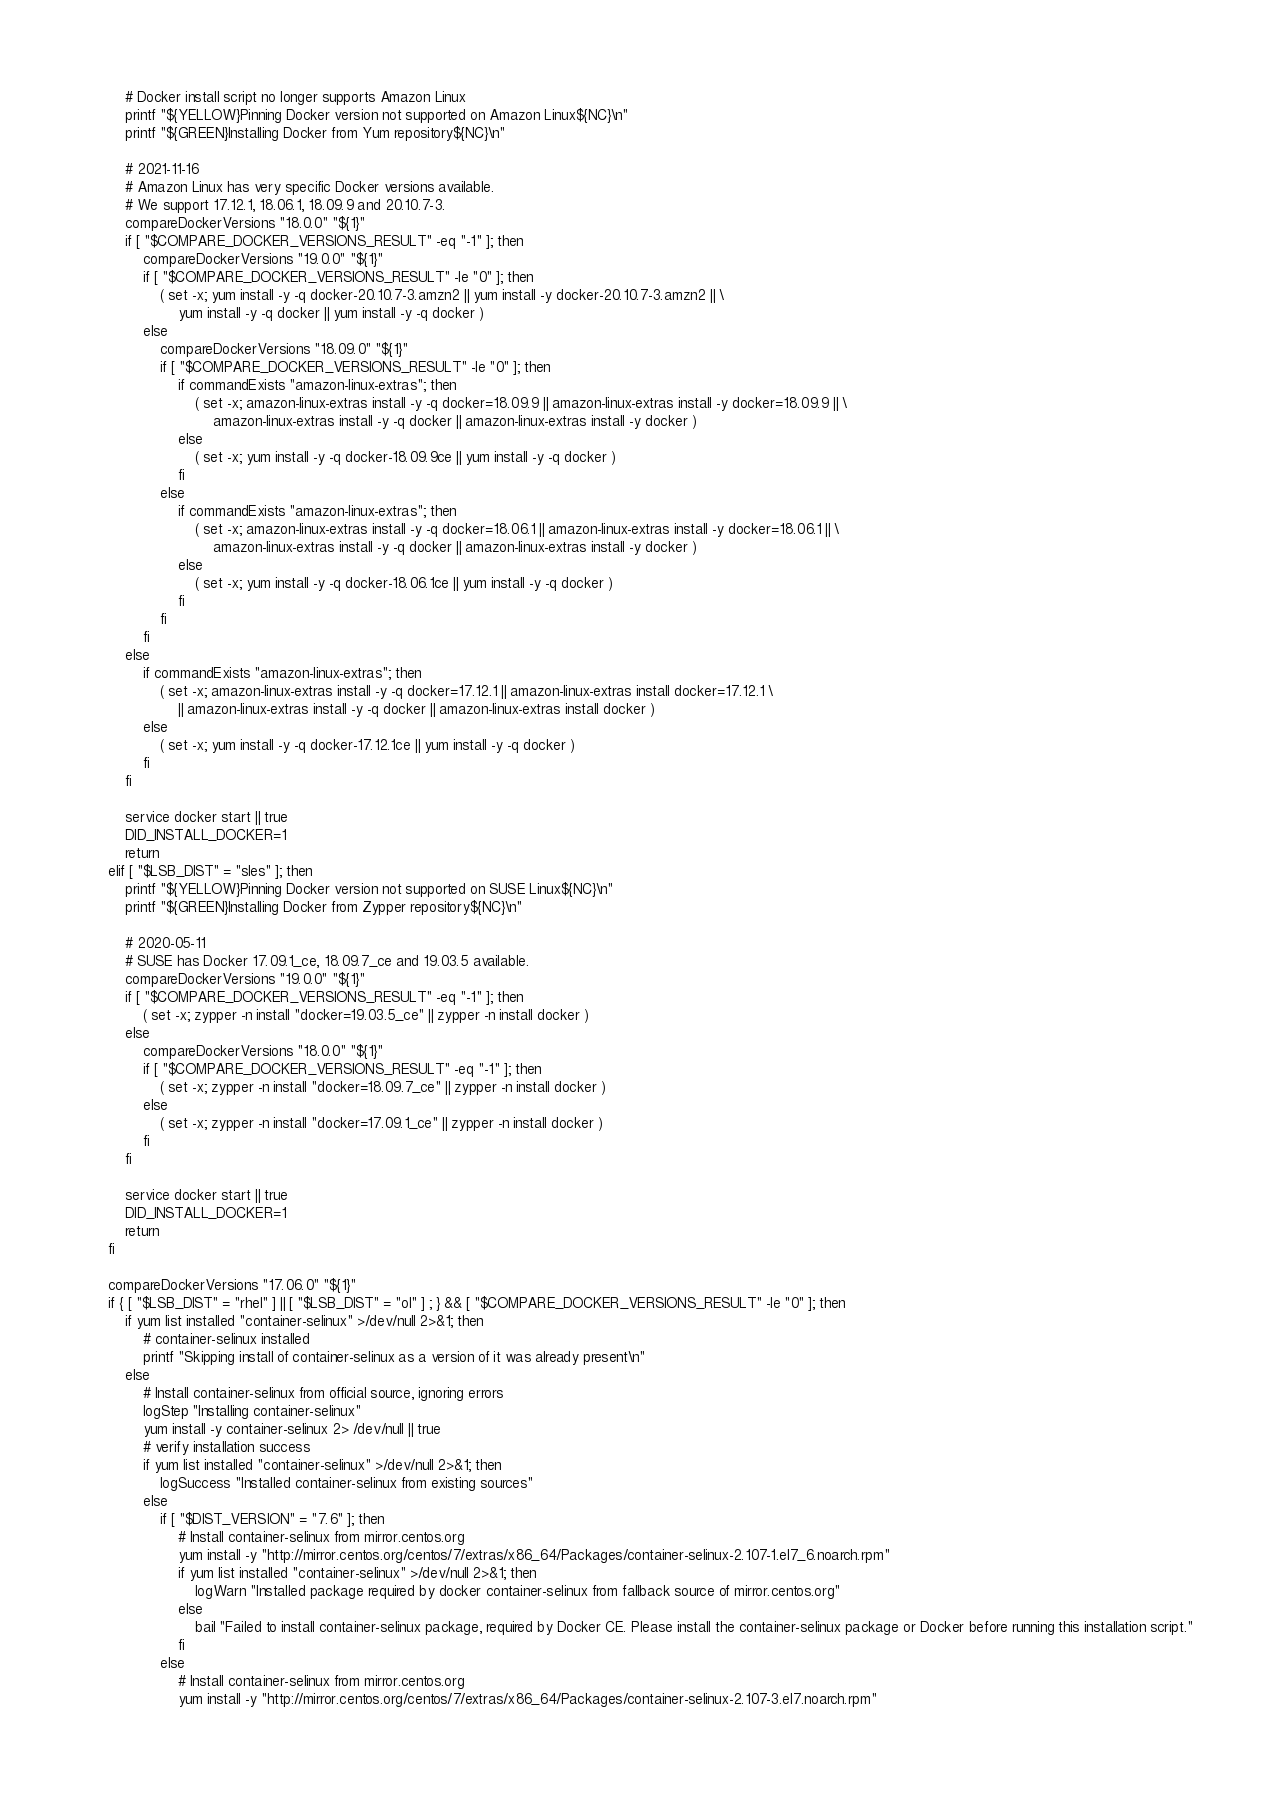Convert code to text. <code><loc_0><loc_0><loc_500><loc_500><_Bash_>        # Docker install script no longer supports Amazon Linux
        printf "${YELLOW}Pinning Docker version not supported on Amazon Linux${NC}\n"
        printf "${GREEN}Installing Docker from Yum repository${NC}\n"

        # 2021-11-16
        # Amazon Linux has very specific Docker versions available.
        # We support 17.12.1, 18.06.1, 18.09.9 and 20.10.7-3.
        compareDockerVersions "18.0.0" "${1}"
        if [ "$COMPARE_DOCKER_VERSIONS_RESULT" -eq "-1" ]; then
            compareDockerVersions "19.0.0" "${1}"
            if [ "$COMPARE_DOCKER_VERSIONS_RESULT" -le "0" ]; then
                ( set -x; yum install -y -q docker-20.10.7-3.amzn2 || yum install -y docker-20.10.7-3.amzn2 || \
                    yum install -y -q docker || yum install -y -q docker )
            else
                compareDockerVersions "18.09.0" "${1}"
                if [ "$COMPARE_DOCKER_VERSIONS_RESULT" -le "0" ]; then
                    if commandExists "amazon-linux-extras"; then
                        ( set -x; amazon-linux-extras install -y -q docker=18.09.9 || amazon-linux-extras install -y docker=18.09.9 || \
                            amazon-linux-extras install -y -q docker || amazon-linux-extras install -y docker )
                    else
                        ( set -x; yum install -y -q docker-18.09.9ce || yum install -y -q docker )
                    fi
                else
                    if commandExists "amazon-linux-extras"; then
                        ( set -x; amazon-linux-extras install -y -q docker=18.06.1 || amazon-linux-extras install -y docker=18.06.1 || \
                            amazon-linux-extras install -y -q docker || amazon-linux-extras install -y docker )
                    else
                        ( set -x; yum install -y -q docker-18.06.1ce || yum install -y -q docker )
                    fi
                fi
            fi
        else
            if commandExists "amazon-linux-extras"; then
                ( set -x; amazon-linux-extras install -y -q docker=17.12.1 || amazon-linux-extras install docker=17.12.1 \
                    || amazon-linux-extras install -y -q docker || amazon-linux-extras install docker )
            else
                ( set -x; yum install -y -q docker-17.12.1ce || yum install -y -q docker )
            fi
        fi

        service docker start || true
        DID_INSTALL_DOCKER=1
        return
    elif [ "$LSB_DIST" = "sles" ]; then
        printf "${YELLOW}Pinning Docker version not supported on SUSE Linux${NC}\n"
        printf "${GREEN}Installing Docker from Zypper repository${NC}\n"

        # 2020-05-11
        # SUSE has Docker 17.09.1_ce, 18.09.7_ce and 19.03.5 available.
        compareDockerVersions "19.0.0" "${1}"
        if [ "$COMPARE_DOCKER_VERSIONS_RESULT" -eq "-1" ]; then
            ( set -x; zypper -n install "docker=19.03.5_ce" || zypper -n install docker )
        else
            compareDockerVersions "18.0.0" "${1}"
            if [ "$COMPARE_DOCKER_VERSIONS_RESULT" -eq "-1" ]; then
                ( set -x; zypper -n install "docker=18.09.7_ce" || zypper -n install docker )
            else
                ( set -x; zypper -n install "docker=17.09.1_ce" || zypper -n install docker )
            fi
        fi

        service docker start || true
        DID_INSTALL_DOCKER=1
        return
    fi

    compareDockerVersions "17.06.0" "${1}"
    if { [ "$LSB_DIST" = "rhel" ] || [ "$LSB_DIST" = "ol" ] ; } && [ "$COMPARE_DOCKER_VERSIONS_RESULT" -le "0" ]; then
        if yum list installed "container-selinux" >/dev/null 2>&1; then
            # container-selinux installed
            printf "Skipping install of container-selinux as a version of it was already present\n"
        else
            # Install container-selinux from official source, ignoring errors
            logStep "Installing container-selinux"
            yum install -y container-selinux 2> /dev/null || true
            # verify installation success
            if yum list installed "container-selinux" >/dev/null 2>&1; then
                logSuccess "Installed container-selinux from existing sources"
            else
                if [ "$DIST_VERSION" = "7.6" ]; then
                    # Install container-selinux from mirror.centos.org
                    yum install -y "http://mirror.centos.org/centos/7/extras/x86_64/Packages/container-selinux-2.107-1.el7_6.noarch.rpm"
                    if yum list installed "container-selinux" >/dev/null 2>&1; then
                        logWarn "Installed package required by docker container-selinux from fallback source of mirror.centos.org"
                    else
                        bail "Failed to install container-selinux package, required by Docker CE. Please install the container-selinux package or Docker before running this installation script."
                    fi
                else
                    # Install container-selinux from mirror.centos.org
                    yum install -y "http://mirror.centos.org/centos/7/extras/x86_64/Packages/container-selinux-2.107-3.el7.noarch.rpm"</code> 